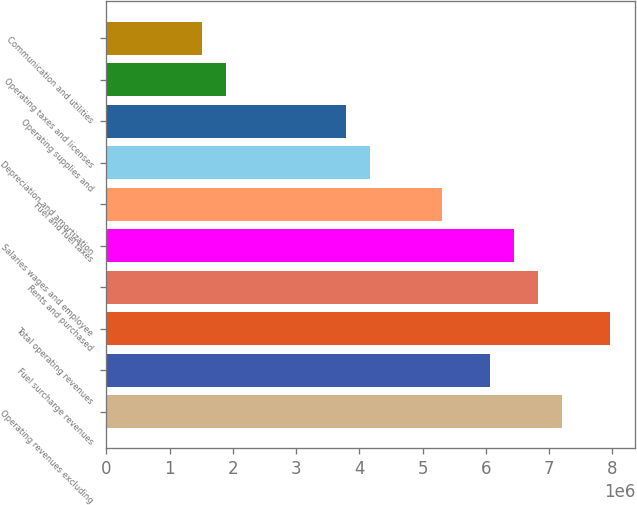<chart> <loc_0><loc_0><loc_500><loc_500><bar_chart><fcel>Operating revenues excluding<fcel>Fuel surcharge revenues<fcel>Total operating revenues<fcel>Rents and purchased<fcel>Salaries wages and employee<fcel>Fuel and fuel taxes<fcel>Depreciation and amortization<fcel>Operating supplies and<fcel>Operating taxes and licenses<fcel>Communication and utilities<nl><fcel>7.20762e+06<fcel>6.06958e+06<fcel>7.96632e+06<fcel>6.82827e+06<fcel>6.44892e+06<fcel>5.31088e+06<fcel>4.17283e+06<fcel>3.79348e+06<fcel>1.89674e+06<fcel>1.51739e+06<nl></chart> 